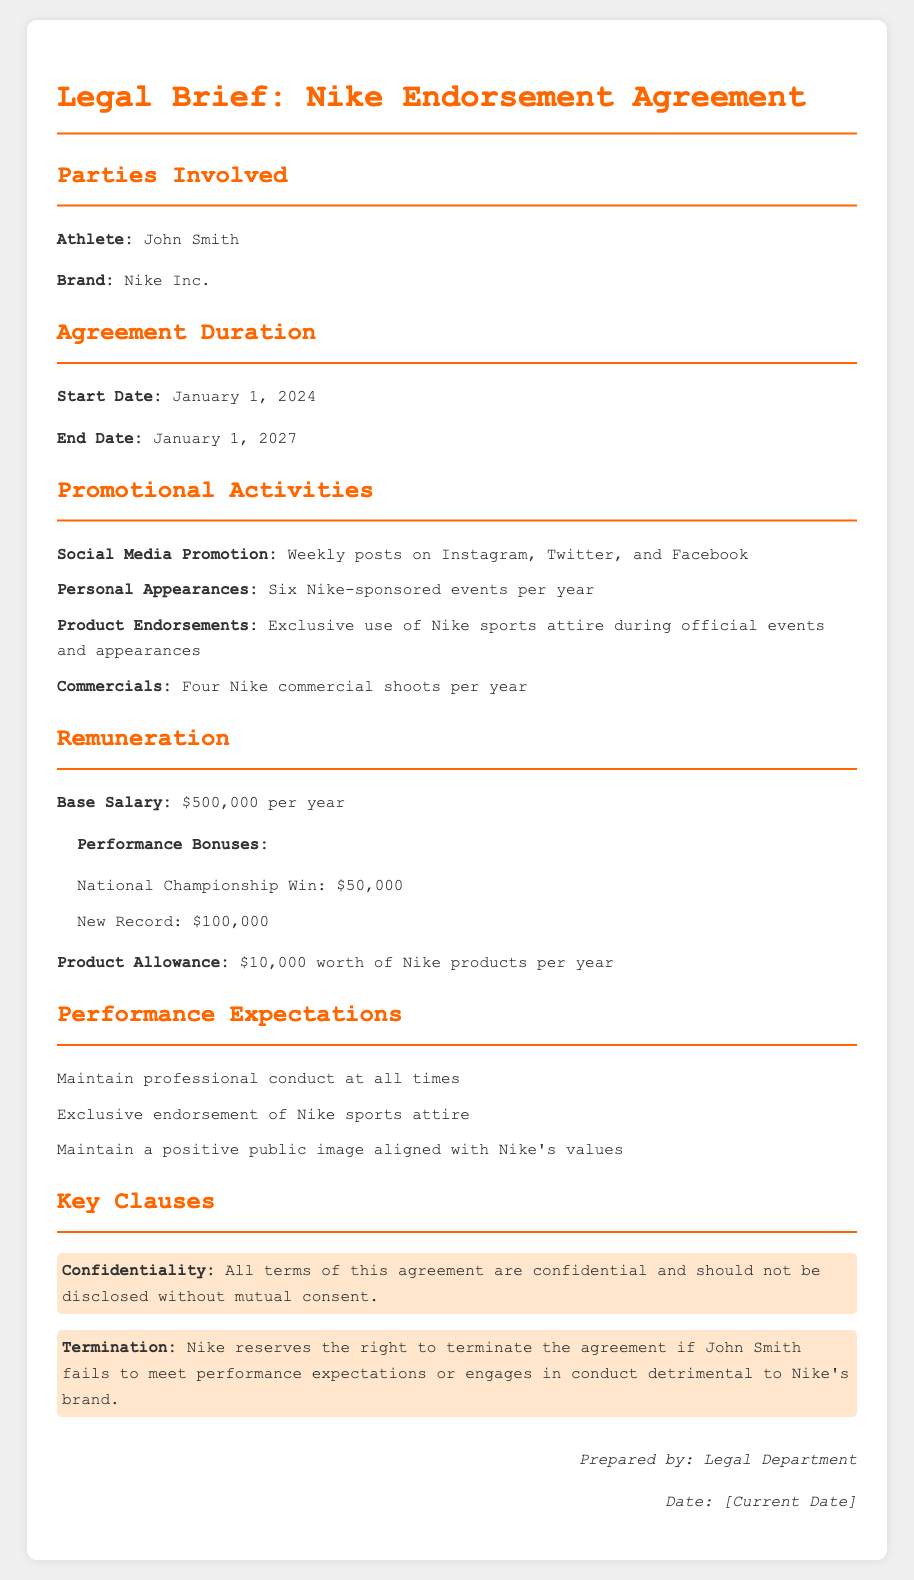What is the name of the athlete in the endorsement agreement? The athlete's name is specified in the document as John Smith.
Answer: John Smith What is the start date of the agreement? The start date is mentioned in the document under the Agreement Duration section as January 1, 2024.
Answer: January 1, 2024 How much is the base salary per year? The base salary is detailed in the Remuneration section of the document, which states $500,000 per year.
Answer: $500,000 What is one of the promotional activities listed in the agreement? The document outlines several promotional activities, including social media promotion, personal appearances, and product endorsements; one example is weekly posts on social media.
Answer: Weekly posts on Instagram, Twitter, and Facebook What is the total performance bonus for setting a new record? The performance bonuses for achievements are listed in the document, specifying $100,000 for a new record.
Answer: $100,000 What does the confidentiality clause prohibit? The confidentiality clause specifies that all terms of the agreement are confidential and cannot be disclosed without mutual consent, explaining the prohibition.
Answer: Disclosure without mutual consent How many Nike-sponsored events must the athlete attend each year? The document specifies that the athlete is required to attend six Nike-sponsored events per year in the Promotional Activities section.
Answer: Six What happens if the athlete fails to meet performance expectations? The termination clause states that Nike reserves the right to terminate the agreement if the athlete fails to meet performance expectations or engages in detrimental conduct.
Answer: Termination of the agreement What is the end date of the endorsement agreement? The end date is detailed in the Agreement Duration section, indicating that it concludes on January 1, 2027.
Answer: January 1, 2027 